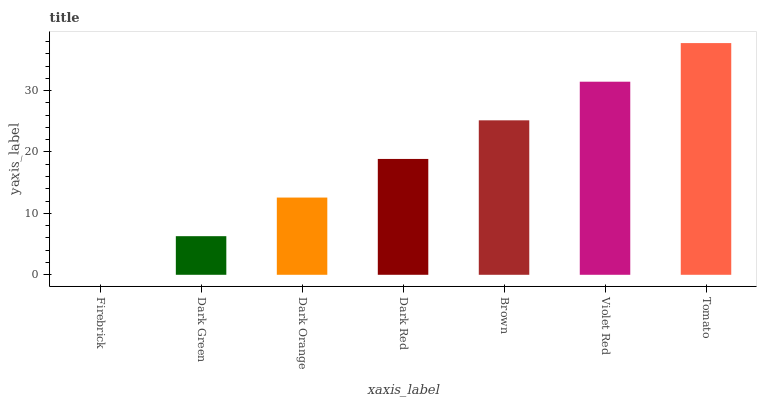Is Firebrick the minimum?
Answer yes or no. Yes. Is Tomato the maximum?
Answer yes or no. Yes. Is Dark Green the minimum?
Answer yes or no. No. Is Dark Green the maximum?
Answer yes or no. No. Is Dark Green greater than Firebrick?
Answer yes or no. Yes. Is Firebrick less than Dark Green?
Answer yes or no. Yes. Is Firebrick greater than Dark Green?
Answer yes or no. No. Is Dark Green less than Firebrick?
Answer yes or no. No. Is Dark Red the high median?
Answer yes or no. Yes. Is Dark Red the low median?
Answer yes or no. Yes. Is Violet Red the high median?
Answer yes or no. No. Is Tomato the low median?
Answer yes or no. No. 